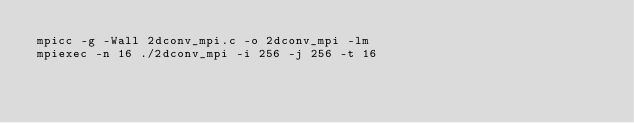<code> <loc_0><loc_0><loc_500><loc_500><_Bash_>mpicc -g -Wall 2dconv_mpi.c -o 2dconv_mpi -lm
mpiexec -n 16 ./2dconv_mpi -i 256 -j 256 -t 16
</code> 